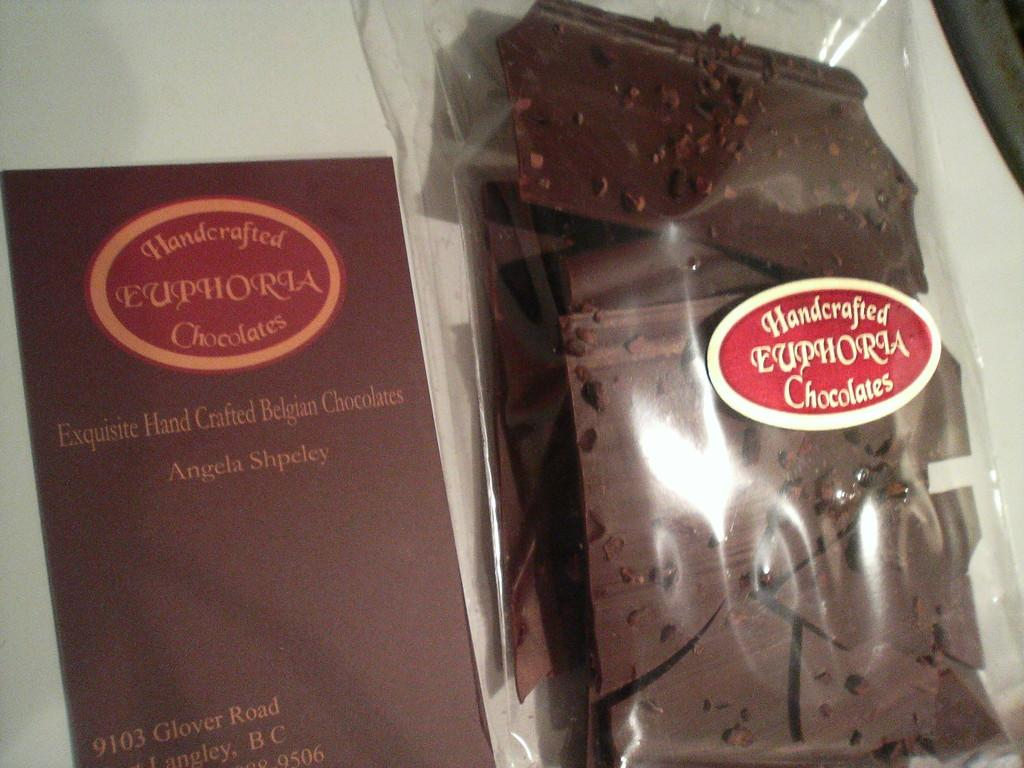<image>
Provide a brief description of the given image. A bag of handcrafted euphoria chocolates from Angela Shpeley. 